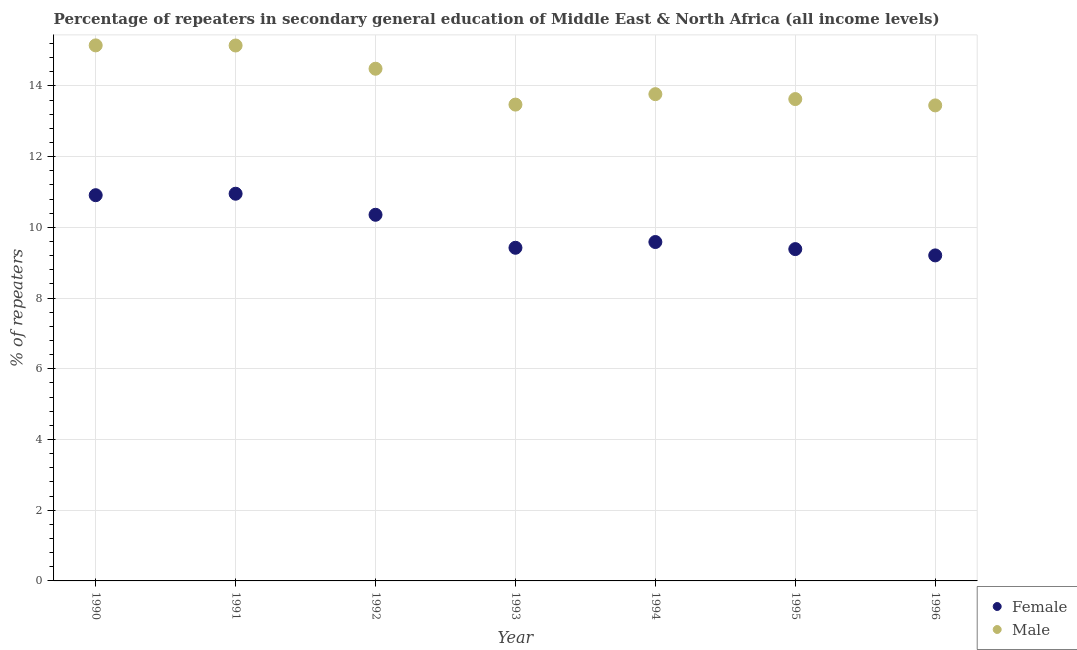How many different coloured dotlines are there?
Your answer should be very brief. 2. What is the percentage of male repeaters in 1994?
Your answer should be very brief. 13.77. Across all years, what is the maximum percentage of female repeaters?
Give a very brief answer. 10.95. Across all years, what is the minimum percentage of male repeaters?
Offer a terse response. 13.45. In which year was the percentage of female repeaters minimum?
Offer a terse response. 1996. What is the total percentage of female repeaters in the graph?
Your response must be concise. 69.83. What is the difference between the percentage of male repeaters in 1990 and that in 1993?
Make the answer very short. 1.68. What is the difference between the percentage of female repeaters in 1994 and the percentage of male repeaters in 1990?
Your answer should be very brief. -5.56. What is the average percentage of female repeaters per year?
Offer a terse response. 9.98. In the year 1994, what is the difference between the percentage of male repeaters and percentage of female repeaters?
Provide a short and direct response. 4.18. What is the ratio of the percentage of female repeaters in 1992 to that in 1996?
Your answer should be compact. 1.12. Is the percentage of male repeaters in 1993 less than that in 1996?
Offer a very short reply. No. Is the difference between the percentage of male repeaters in 1990 and 1996 greater than the difference between the percentage of female repeaters in 1990 and 1996?
Your answer should be compact. No. What is the difference between the highest and the second highest percentage of female repeaters?
Keep it short and to the point. 0.04. What is the difference between the highest and the lowest percentage of male repeaters?
Provide a succinct answer. 1.7. In how many years, is the percentage of female repeaters greater than the average percentage of female repeaters taken over all years?
Ensure brevity in your answer.  3. How many dotlines are there?
Provide a short and direct response. 2. How many years are there in the graph?
Your answer should be compact. 7. Where does the legend appear in the graph?
Give a very brief answer. Bottom right. How many legend labels are there?
Your answer should be very brief. 2. How are the legend labels stacked?
Offer a very short reply. Vertical. What is the title of the graph?
Your answer should be compact. Percentage of repeaters in secondary general education of Middle East & North Africa (all income levels). Does "Public credit registry" appear as one of the legend labels in the graph?
Provide a succinct answer. No. What is the label or title of the X-axis?
Your response must be concise. Year. What is the label or title of the Y-axis?
Give a very brief answer. % of repeaters. What is the % of repeaters in Female in 1990?
Your answer should be very brief. 10.91. What is the % of repeaters in Male in 1990?
Keep it short and to the point. 15.15. What is the % of repeaters in Female in 1991?
Offer a very short reply. 10.95. What is the % of repeaters in Male in 1991?
Provide a short and direct response. 15.15. What is the % of repeaters of Female in 1992?
Keep it short and to the point. 10.36. What is the % of repeaters of Male in 1992?
Make the answer very short. 14.49. What is the % of repeaters in Female in 1993?
Offer a very short reply. 9.42. What is the % of repeaters of Male in 1993?
Give a very brief answer. 13.47. What is the % of repeaters of Female in 1994?
Offer a very short reply. 9.59. What is the % of repeaters of Male in 1994?
Make the answer very short. 13.77. What is the % of repeaters of Female in 1995?
Make the answer very short. 9.39. What is the % of repeaters in Male in 1995?
Offer a very short reply. 13.63. What is the % of repeaters of Female in 1996?
Provide a short and direct response. 9.21. What is the % of repeaters of Male in 1996?
Provide a succinct answer. 13.45. Across all years, what is the maximum % of repeaters in Female?
Keep it short and to the point. 10.95. Across all years, what is the maximum % of repeaters in Male?
Give a very brief answer. 15.15. Across all years, what is the minimum % of repeaters in Female?
Offer a very short reply. 9.21. Across all years, what is the minimum % of repeaters of Male?
Your answer should be compact. 13.45. What is the total % of repeaters of Female in the graph?
Ensure brevity in your answer.  69.83. What is the total % of repeaters of Male in the graph?
Your answer should be very brief. 99.11. What is the difference between the % of repeaters in Female in 1990 and that in 1991?
Make the answer very short. -0.04. What is the difference between the % of repeaters of Male in 1990 and that in 1991?
Ensure brevity in your answer.  0. What is the difference between the % of repeaters in Female in 1990 and that in 1992?
Offer a very short reply. 0.55. What is the difference between the % of repeaters in Male in 1990 and that in 1992?
Ensure brevity in your answer.  0.66. What is the difference between the % of repeaters in Female in 1990 and that in 1993?
Provide a succinct answer. 1.49. What is the difference between the % of repeaters of Male in 1990 and that in 1993?
Your answer should be very brief. 1.68. What is the difference between the % of repeaters of Female in 1990 and that in 1994?
Make the answer very short. 1.32. What is the difference between the % of repeaters of Male in 1990 and that in 1994?
Your answer should be very brief. 1.38. What is the difference between the % of repeaters of Female in 1990 and that in 1995?
Offer a terse response. 1.52. What is the difference between the % of repeaters of Male in 1990 and that in 1995?
Keep it short and to the point. 1.52. What is the difference between the % of repeaters in Female in 1990 and that in 1996?
Provide a short and direct response. 1.7. What is the difference between the % of repeaters of Male in 1990 and that in 1996?
Provide a succinct answer. 1.7. What is the difference between the % of repeaters of Female in 1991 and that in 1992?
Offer a very short reply. 0.6. What is the difference between the % of repeaters of Male in 1991 and that in 1992?
Provide a succinct answer. 0.66. What is the difference between the % of repeaters in Female in 1991 and that in 1993?
Your response must be concise. 1.53. What is the difference between the % of repeaters in Male in 1991 and that in 1993?
Provide a short and direct response. 1.67. What is the difference between the % of repeaters of Female in 1991 and that in 1994?
Your response must be concise. 1.37. What is the difference between the % of repeaters in Male in 1991 and that in 1994?
Offer a terse response. 1.38. What is the difference between the % of repeaters in Female in 1991 and that in 1995?
Provide a succinct answer. 1.57. What is the difference between the % of repeaters of Male in 1991 and that in 1995?
Your answer should be very brief. 1.52. What is the difference between the % of repeaters of Female in 1991 and that in 1996?
Your answer should be very brief. 1.74. What is the difference between the % of repeaters in Male in 1991 and that in 1996?
Ensure brevity in your answer.  1.69. What is the difference between the % of repeaters in Female in 1992 and that in 1993?
Provide a succinct answer. 0.93. What is the difference between the % of repeaters in Male in 1992 and that in 1993?
Keep it short and to the point. 1.01. What is the difference between the % of repeaters in Female in 1992 and that in 1994?
Give a very brief answer. 0.77. What is the difference between the % of repeaters of Male in 1992 and that in 1994?
Your answer should be compact. 0.72. What is the difference between the % of repeaters in Male in 1992 and that in 1995?
Keep it short and to the point. 0.86. What is the difference between the % of repeaters in Female in 1992 and that in 1996?
Make the answer very short. 1.15. What is the difference between the % of repeaters of Male in 1992 and that in 1996?
Make the answer very short. 1.04. What is the difference between the % of repeaters of Female in 1993 and that in 1994?
Your answer should be compact. -0.16. What is the difference between the % of repeaters of Male in 1993 and that in 1994?
Make the answer very short. -0.3. What is the difference between the % of repeaters in Female in 1993 and that in 1995?
Offer a terse response. 0.04. What is the difference between the % of repeaters in Male in 1993 and that in 1995?
Your answer should be very brief. -0.16. What is the difference between the % of repeaters in Female in 1993 and that in 1996?
Offer a terse response. 0.22. What is the difference between the % of repeaters of Male in 1993 and that in 1996?
Keep it short and to the point. 0.02. What is the difference between the % of repeaters in Female in 1994 and that in 1995?
Ensure brevity in your answer.  0.2. What is the difference between the % of repeaters in Male in 1994 and that in 1995?
Give a very brief answer. 0.14. What is the difference between the % of repeaters in Female in 1994 and that in 1996?
Provide a short and direct response. 0.38. What is the difference between the % of repeaters in Male in 1994 and that in 1996?
Provide a succinct answer. 0.32. What is the difference between the % of repeaters of Female in 1995 and that in 1996?
Your answer should be very brief. 0.18. What is the difference between the % of repeaters of Male in 1995 and that in 1996?
Your response must be concise. 0.18. What is the difference between the % of repeaters in Female in 1990 and the % of repeaters in Male in 1991?
Ensure brevity in your answer.  -4.23. What is the difference between the % of repeaters in Female in 1990 and the % of repeaters in Male in 1992?
Give a very brief answer. -3.58. What is the difference between the % of repeaters of Female in 1990 and the % of repeaters of Male in 1993?
Offer a very short reply. -2.56. What is the difference between the % of repeaters in Female in 1990 and the % of repeaters in Male in 1994?
Give a very brief answer. -2.86. What is the difference between the % of repeaters in Female in 1990 and the % of repeaters in Male in 1995?
Make the answer very short. -2.72. What is the difference between the % of repeaters in Female in 1990 and the % of repeaters in Male in 1996?
Your response must be concise. -2.54. What is the difference between the % of repeaters in Female in 1991 and the % of repeaters in Male in 1992?
Give a very brief answer. -3.54. What is the difference between the % of repeaters in Female in 1991 and the % of repeaters in Male in 1993?
Make the answer very short. -2.52. What is the difference between the % of repeaters in Female in 1991 and the % of repeaters in Male in 1994?
Provide a short and direct response. -2.82. What is the difference between the % of repeaters in Female in 1991 and the % of repeaters in Male in 1995?
Your answer should be very brief. -2.68. What is the difference between the % of repeaters of Female in 1991 and the % of repeaters of Male in 1996?
Ensure brevity in your answer.  -2.5. What is the difference between the % of repeaters in Female in 1992 and the % of repeaters in Male in 1993?
Give a very brief answer. -3.12. What is the difference between the % of repeaters in Female in 1992 and the % of repeaters in Male in 1994?
Your answer should be very brief. -3.41. What is the difference between the % of repeaters of Female in 1992 and the % of repeaters of Male in 1995?
Provide a short and direct response. -3.27. What is the difference between the % of repeaters of Female in 1992 and the % of repeaters of Male in 1996?
Provide a short and direct response. -3.09. What is the difference between the % of repeaters in Female in 1993 and the % of repeaters in Male in 1994?
Keep it short and to the point. -4.35. What is the difference between the % of repeaters of Female in 1993 and the % of repeaters of Male in 1995?
Offer a very short reply. -4.21. What is the difference between the % of repeaters of Female in 1993 and the % of repeaters of Male in 1996?
Offer a very short reply. -4.03. What is the difference between the % of repeaters in Female in 1994 and the % of repeaters in Male in 1995?
Offer a very short reply. -4.04. What is the difference between the % of repeaters in Female in 1994 and the % of repeaters in Male in 1996?
Provide a short and direct response. -3.86. What is the difference between the % of repeaters of Female in 1995 and the % of repeaters of Male in 1996?
Provide a short and direct response. -4.06. What is the average % of repeaters of Female per year?
Offer a very short reply. 9.97. What is the average % of repeaters in Male per year?
Your response must be concise. 14.16. In the year 1990, what is the difference between the % of repeaters in Female and % of repeaters in Male?
Provide a short and direct response. -4.24. In the year 1991, what is the difference between the % of repeaters in Female and % of repeaters in Male?
Give a very brief answer. -4.19. In the year 1992, what is the difference between the % of repeaters in Female and % of repeaters in Male?
Provide a short and direct response. -4.13. In the year 1993, what is the difference between the % of repeaters of Female and % of repeaters of Male?
Your response must be concise. -4.05. In the year 1994, what is the difference between the % of repeaters of Female and % of repeaters of Male?
Give a very brief answer. -4.18. In the year 1995, what is the difference between the % of repeaters in Female and % of repeaters in Male?
Your response must be concise. -4.24. In the year 1996, what is the difference between the % of repeaters of Female and % of repeaters of Male?
Your answer should be compact. -4.24. What is the ratio of the % of repeaters in Female in 1990 to that in 1991?
Your answer should be compact. 1. What is the ratio of the % of repeaters of Male in 1990 to that in 1991?
Provide a succinct answer. 1. What is the ratio of the % of repeaters in Female in 1990 to that in 1992?
Provide a short and direct response. 1.05. What is the ratio of the % of repeaters in Male in 1990 to that in 1992?
Keep it short and to the point. 1.05. What is the ratio of the % of repeaters in Female in 1990 to that in 1993?
Offer a terse response. 1.16. What is the ratio of the % of repeaters in Male in 1990 to that in 1993?
Your response must be concise. 1.12. What is the ratio of the % of repeaters in Female in 1990 to that in 1994?
Offer a very short reply. 1.14. What is the ratio of the % of repeaters in Male in 1990 to that in 1994?
Offer a very short reply. 1.1. What is the ratio of the % of repeaters of Female in 1990 to that in 1995?
Make the answer very short. 1.16. What is the ratio of the % of repeaters in Male in 1990 to that in 1995?
Offer a terse response. 1.11. What is the ratio of the % of repeaters of Female in 1990 to that in 1996?
Provide a short and direct response. 1.18. What is the ratio of the % of repeaters of Male in 1990 to that in 1996?
Your response must be concise. 1.13. What is the ratio of the % of repeaters of Female in 1991 to that in 1992?
Ensure brevity in your answer.  1.06. What is the ratio of the % of repeaters of Male in 1991 to that in 1992?
Ensure brevity in your answer.  1.05. What is the ratio of the % of repeaters of Female in 1991 to that in 1993?
Your answer should be very brief. 1.16. What is the ratio of the % of repeaters in Male in 1991 to that in 1993?
Your response must be concise. 1.12. What is the ratio of the % of repeaters in Female in 1991 to that in 1994?
Your answer should be very brief. 1.14. What is the ratio of the % of repeaters in Male in 1991 to that in 1994?
Your answer should be very brief. 1.1. What is the ratio of the % of repeaters in Female in 1991 to that in 1995?
Make the answer very short. 1.17. What is the ratio of the % of repeaters in Male in 1991 to that in 1995?
Your answer should be compact. 1.11. What is the ratio of the % of repeaters of Female in 1991 to that in 1996?
Keep it short and to the point. 1.19. What is the ratio of the % of repeaters in Male in 1991 to that in 1996?
Ensure brevity in your answer.  1.13. What is the ratio of the % of repeaters of Female in 1992 to that in 1993?
Give a very brief answer. 1.1. What is the ratio of the % of repeaters of Male in 1992 to that in 1993?
Make the answer very short. 1.08. What is the ratio of the % of repeaters of Female in 1992 to that in 1994?
Ensure brevity in your answer.  1.08. What is the ratio of the % of repeaters of Male in 1992 to that in 1994?
Your answer should be compact. 1.05. What is the ratio of the % of repeaters in Female in 1992 to that in 1995?
Make the answer very short. 1.1. What is the ratio of the % of repeaters of Male in 1992 to that in 1995?
Provide a succinct answer. 1.06. What is the ratio of the % of repeaters in Female in 1992 to that in 1996?
Offer a very short reply. 1.12. What is the ratio of the % of repeaters of Male in 1992 to that in 1996?
Keep it short and to the point. 1.08. What is the ratio of the % of repeaters of Male in 1993 to that in 1994?
Provide a short and direct response. 0.98. What is the ratio of the % of repeaters of Female in 1993 to that in 1995?
Keep it short and to the point. 1. What is the ratio of the % of repeaters of Female in 1993 to that in 1996?
Keep it short and to the point. 1.02. What is the ratio of the % of repeaters in Male in 1993 to that in 1996?
Ensure brevity in your answer.  1. What is the ratio of the % of repeaters in Female in 1994 to that in 1995?
Your answer should be compact. 1.02. What is the ratio of the % of repeaters of Male in 1994 to that in 1995?
Provide a short and direct response. 1.01. What is the ratio of the % of repeaters in Female in 1994 to that in 1996?
Your response must be concise. 1.04. What is the ratio of the % of repeaters of Male in 1994 to that in 1996?
Offer a very short reply. 1.02. What is the ratio of the % of repeaters in Female in 1995 to that in 1996?
Your response must be concise. 1.02. What is the ratio of the % of repeaters in Male in 1995 to that in 1996?
Your answer should be compact. 1.01. What is the difference between the highest and the second highest % of repeaters of Female?
Provide a succinct answer. 0.04. What is the difference between the highest and the second highest % of repeaters of Male?
Your answer should be compact. 0. What is the difference between the highest and the lowest % of repeaters in Female?
Offer a very short reply. 1.74. What is the difference between the highest and the lowest % of repeaters of Male?
Your response must be concise. 1.7. 